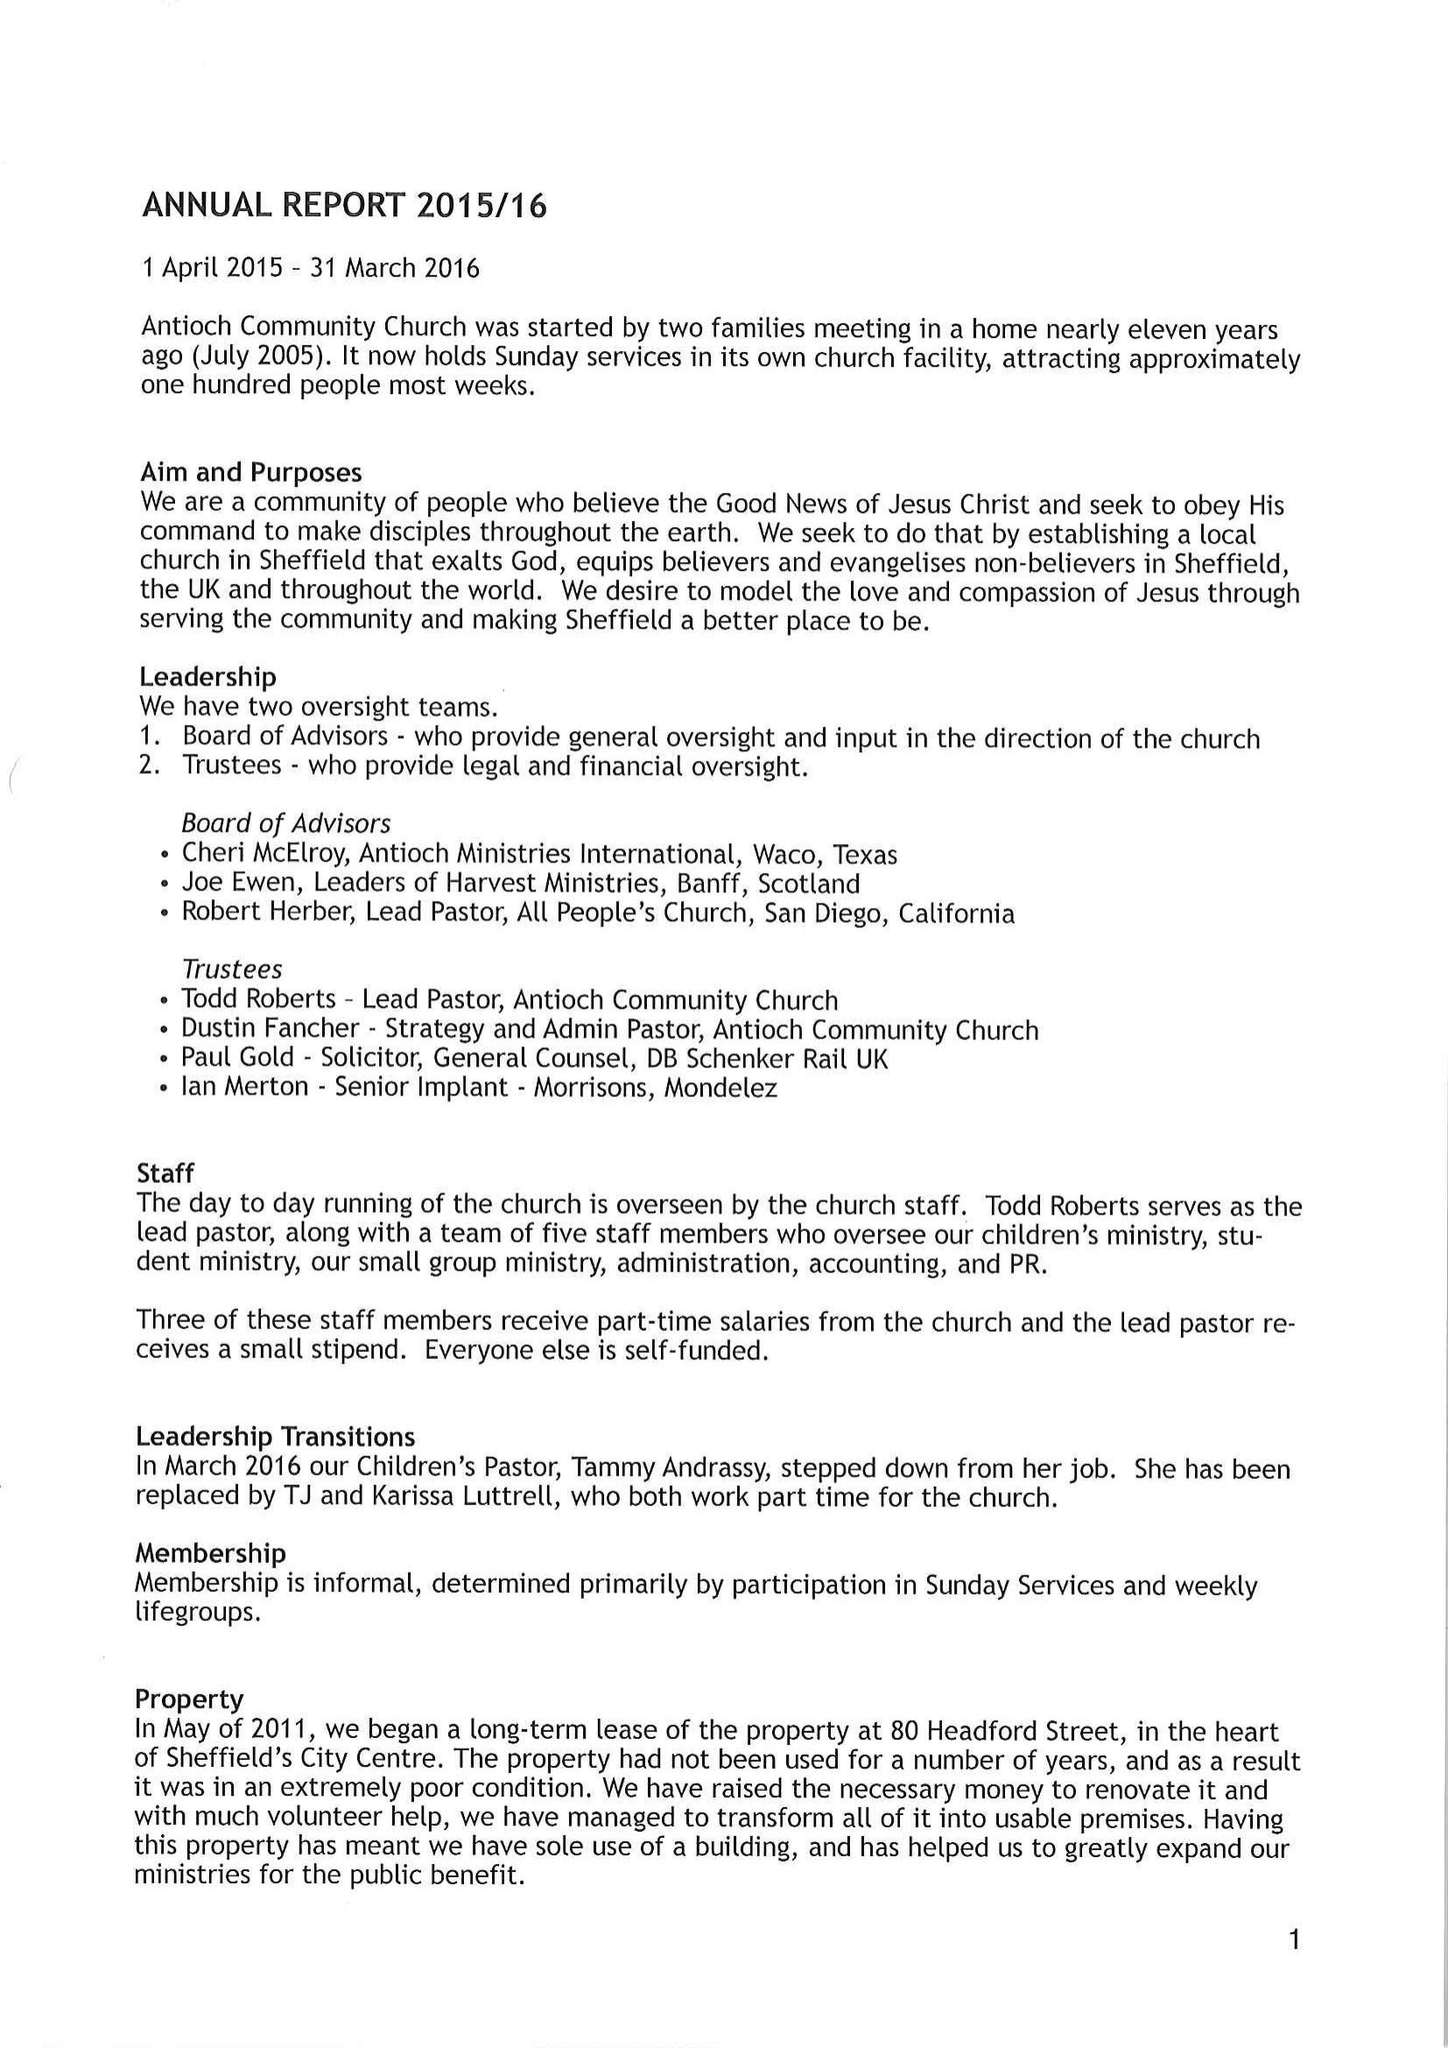What is the value for the income_annually_in_british_pounds?
Answer the question using a single word or phrase. None 